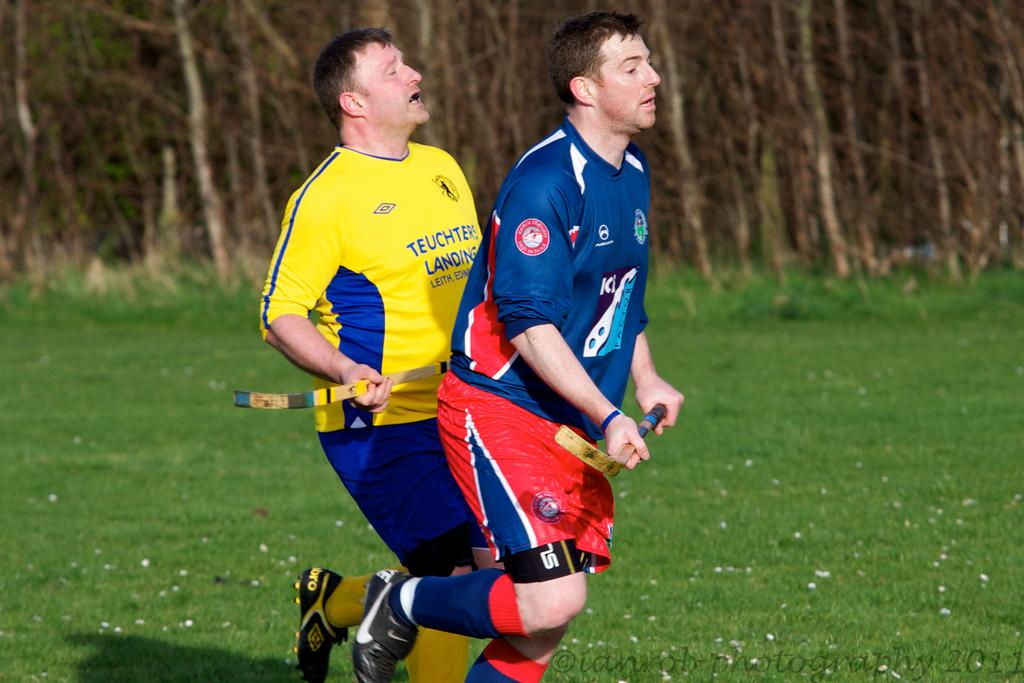How many people are in the image? There are two persons in the image. What are the persons doing in the image? The persons are running on a round. What are the persons holding while running? The persons are holding objects. What can be seen in the background of the image? There are trees visible in the background of the image. What type of grip does the quince have on the round in the image? There is no quince present in the image, and therefore no grip can be observed. 